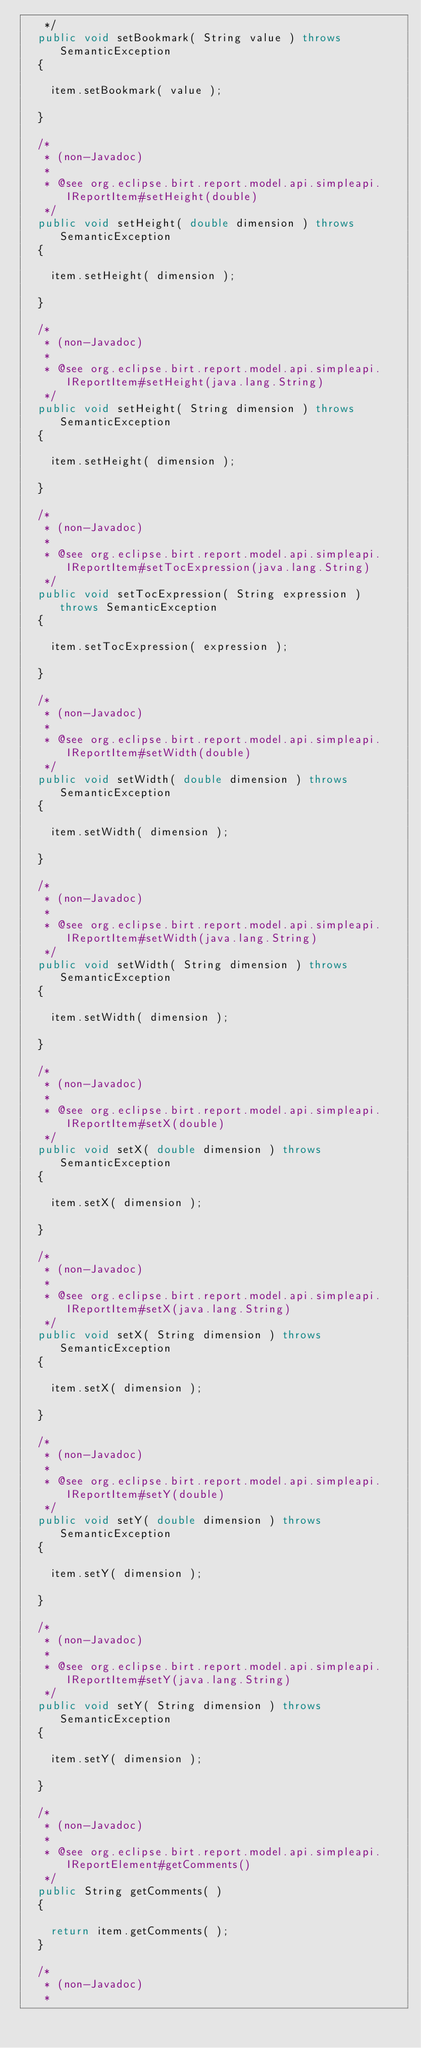<code> <loc_0><loc_0><loc_500><loc_500><_Java_>	 */
	public void setBookmark( String value ) throws SemanticException
	{

		item.setBookmark( value );

	}

	/*
	 * (non-Javadoc)
	 * 
	 * @see org.eclipse.birt.report.model.api.simpleapi.IReportItem#setHeight(double)
	 */
	public void setHeight( double dimension ) throws SemanticException
	{

		item.setHeight( dimension );

	}

	/*
	 * (non-Javadoc)
	 * 
	 * @see org.eclipse.birt.report.model.api.simpleapi.IReportItem#setHeight(java.lang.String)
	 */
	public void setHeight( String dimension ) throws SemanticException
	{

		item.setHeight( dimension );

	}

	/*
	 * (non-Javadoc)
	 * 
	 * @see org.eclipse.birt.report.model.api.simpleapi.IReportItem#setTocExpression(java.lang.String)
	 */
	public void setTocExpression( String expression ) throws SemanticException
	{

		item.setTocExpression( expression );

	}

	/*
	 * (non-Javadoc)
	 * 
	 * @see org.eclipse.birt.report.model.api.simpleapi.IReportItem#setWidth(double)
	 */
	public void setWidth( double dimension ) throws SemanticException
	{

		item.setWidth( dimension );

	}

	/*
	 * (non-Javadoc)
	 * 
	 * @see org.eclipse.birt.report.model.api.simpleapi.IReportItem#setWidth(java.lang.String)
	 */
	public void setWidth( String dimension ) throws SemanticException
	{

		item.setWidth( dimension );

	}

	/*
	 * (non-Javadoc)
	 * 
	 * @see org.eclipse.birt.report.model.api.simpleapi.IReportItem#setX(double)
	 */
	public void setX( double dimension ) throws SemanticException
	{

		item.setX( dimension );

	}

	/*
	 * (non-Javadoc)
	 * 
	 * @see org.eclipse.birt.report.model.api.simpleapi.IReportItem#setX(java.lang.String)
	 */
	public void setX( String dimension ) throws SemanticException
	{

		item.setX( dimension );

	}

	/*
	 * (non-Javadoc)
	 * 
	 * @see org.eclipse.birt.report.model.api.simpleapi.IReportItem#setY(double)
	 */
	public void setY( double dimension ) throws SemanticException
	{

		item.setY( dimension );

	}

	/*
	 * (non-Javadoc)
	 * 
	 * @see org.eclipse.birt.report.model.api.simpleapi.IReportItem#setY(java.lang.String)
	 */
	public void setY( String dimension ) throws SemanticException
	{

		item.setY( dimension );

	}

	/*
	 * (non-Javadoc)
	 * 
	 * @see org.eclipse.birt.report.model.api.simpleapi.IReportElement#getComments()
	 */
	public String getComments( )
	{

		return item.getComments( );
	}

	/*
	 * (non-Javadoc)
	 * </code> 